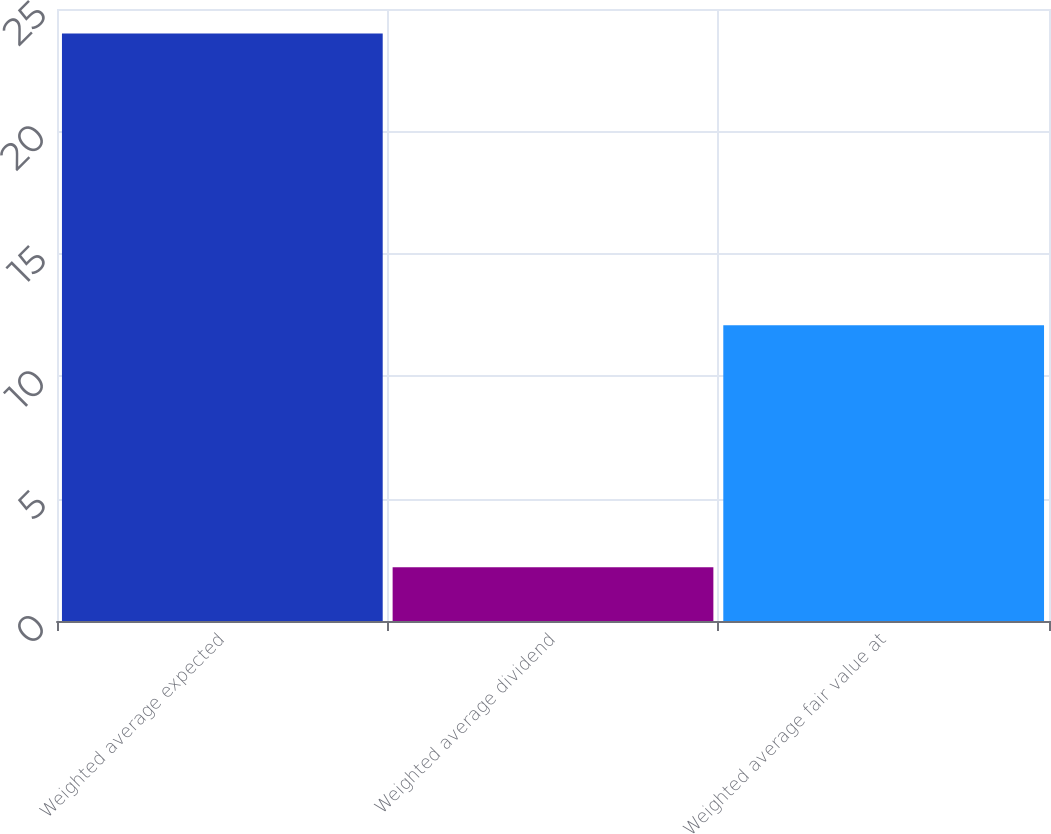Convert chart. <chart><loc_0><loc_0><loc_500><loc_500><bar_chart><fcel>Weighted average expected<fcel>Weighted average dividend<fcel>Weighted average fair value at<nl><fcel>24<fcel>2.2<fcel>12.08<nl></chart> 